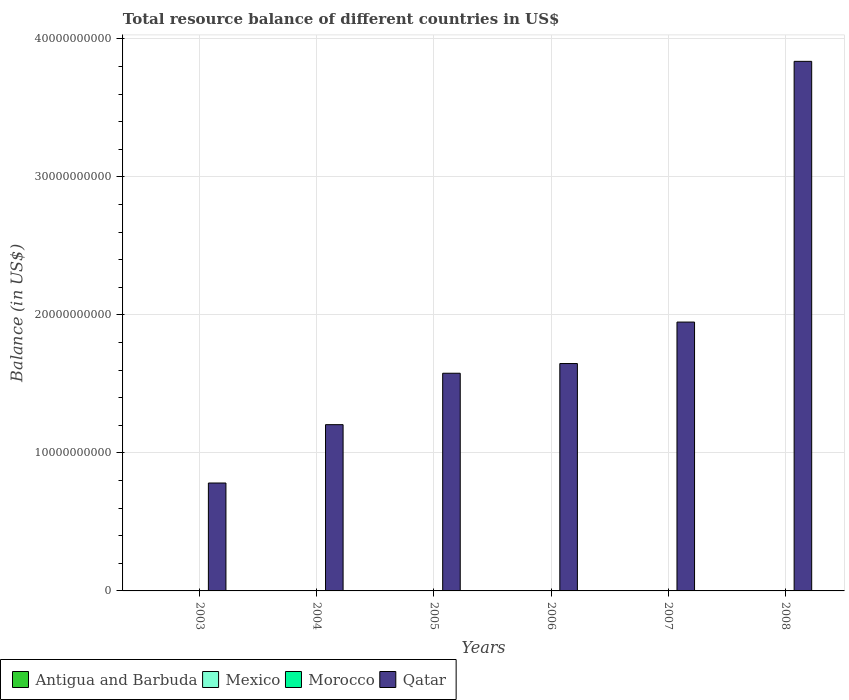How many different coloured bars are there?
Provide a short and direct response. 1. Are the number of bars per tick equal to the number of legend labels?
Your response must be concise. No. How many bars are there on the 6th tick from the left?
Offer a terse response. 1. What is the label of the 2nd group of bars from the left?
Keep it short and to the point. 2004. What is the total resource balance in Antigua and Barbuda in 2007?
Give a very brief answer. 0. Across all years, what is the maximum total resource balance in Qatar?
Ensure brevity in your answer.  3.84e+1. Across all years, what is the minimum total resource balance in Morocco?
Give a very brief answer. 0. What is the difference between the total resource balance in Qatar in 2007 and that in 2008?
Your answer should be compact. -1.89e+1. What is the difference between the total resource balance in Qatar in 2008 and the total resource balance in Antigua and Barbuda in 2005?
Ensure brevity in your answer.  3.84e+1. What is the average total resource balance in Antigua and Barbuda per year?
Make the answer very short. 0. What is the ratio of the total resource balance in Qatar in 2005 to that in 2007?
Make the answer very short. 0.81. Is the total resource balance in Qatar in 2006 less than that in 2008?
Provide a succinct answer. Yes. What is the difference between the highest and the second highest total resource balance in Qatar?
Provide a succinct answer. 1.89e+1. What is the difference between the highest and the lowest total resource balance in Qatar?
Your answer should be very brief. 3.06e+1. Is it the case that in every year, the sum of the total resource balance in Antigua and Barbuda and total resource balance in Morocco is greater than the sum of total resource balance in Qatar and total resource balance in Mexico?
Provide a short and direct response. No. Are all the bars in the graph horizontal?
Your answer should be compact. No. How many years are there in the graph?
Give a very brief answer. 6. What is the difference between two consecutive major ticks on the Y-axis?
Your answer should be compact. 1.00e+1. Are the values on the major ticks of Y-axis written in scientific E-notation?
Your answer should be very brief. No. Does the graph contain any zero values?
Make the answer very short. Yes. Does the graph contain grids?
Provide a succinct answer. Yes. How many legend labels are there?
Provide a short and direct response. 4. How are the legend labels stacked?
Ensure brevity in your answer.  Horizontal. What is the title of the graph?
Provide a short and direct response. Total resource balance of different countries in US$. What is the label or title of the X-axis?
Offer a very short reply. Years. What is the label or title of the Y-axis?
Ensure brevity in your answer.  Balance (in US$). What is the Balance (in US$) in Antigua and Barbuda in 2003?
Your response must be concise. 0. What is the Balance (in US$) in Mexico in 2003?
Offer a very short reply. 0. What is the Balance (in US$) of Morocco in 2003?
Give a very brief answer. 0. What is the Balance (in US$) of Qatar in 2003?
Keep it short and to the point. 7.82e+09. What is the Balance (in US$) of Mexico in 2004?
Offer a terse response. 0. What is the Balance (in US$) in Qatar in 2004?
Provide a succinct answer. 1.20e+1. What is the Balance (in US$) of Mexico in 2005?
Provide a short and direct response. 0. What is the Balance (in US$) of Qatar in 2005?
Your answer should be very brief. 1.58e+1. What is the Balance (in US$) of Mexico in 2006?
Make the answer very short. 0. What is the Balance (in US$) of Qatar in 2006?
Your response must be concise. 1.65e+1. What is the Balance (in US$) of Mexico in 2007?
Provide a succinct answer. 0. What is the Balance (in US$) of Morocco in 2007?
Ensure brevity in your answer.  0. What is the Balance (in US$) of Qatar in 2007?
Your response must be concise. 1.95e+1. What is the Balance (in US$) of Mexico in 2008?
Offer a very short reply. 0. What is the Balance (in US$) in Morocco in 2008?
Keep it short and to the point. 0. What is the Balance (in US$) in Qatar in 2008?
Your response must be concise. 3.84e+1. Across all years, what is the maximum Balance (in US$) in Qatar?
Provide a short and direct response. 3.84e+1. Across all years, what is the minimum Balance (in US$) of Qatar?
Offer a very short reply. 7.82e+09. What is the total Balance (in US$) in Antigua and Barbuda in the graph?
Offer a terse response. 0. What is the total Balance (in US$) in Mexico in the graph?
Your response must be concise. 0. What is the total Balance (in US$) of Qatar in the graph?
Your answer should be very brief. 1.10e+11. What is the difference between the Balance (in US$) of Qatar in 2003 and that in 2004?
Keep it short and to the point. -4.23e+09. What is the difference between the Balance (in US$) of Qatar in 2003 and that in 2005?
Your response must be concise. -7.95e+09. What is the difference between the Balance (in US$) of Qatar in 2003 and that in 2006?
Offer a terse response. -8.66e+09. What is the difference between the Balance (in US$) in Qatar in 2003 and that in 2007?
Your answer should be compact. -1.17e+1. What is the difference between the Balance (in US$) of Qatar in 2003 and that in 2008?
Ensure brevity in your answer.  -3.06e+1. What is the difference between the Balance (in US$) in Qatar in 2004 and that in 2005?
Your answer should be compact. -3.73e+09. What is the difference between the Balance (in US$) in Qatar in 2004 and that in 2006?
Make the answer very short. -4.43e+09. What is the difference between the Balance (in US$) in Qatar in 2004 and that in 2007?
Give a very brief answer. -7.43e+09. What is the difference between the Balance (in US$) in Qatar in 2004 and that in 2008?
Your response must be concise. -2.63e+1. What is the difference between the Balance (in US$) of Qatar in 2005 and that in 2006?
Keep it short and to the point. -7.03e+08. What is the difference between the Balance (in US$) in Qatar in 2005 and that in 2007?
Offer a very short reply. -3.71e+09. What is the difference between the Balance (in US$) of Qatar in 2005 and that in 2008?
Offer a very short reply. -2.26e+1. What is the difference between the Balance (in US$) of Qatar in 2006 and that in 2007?
Keep it short and to the point. -3.00e+09. What is the difference between the Balance (in US$) in Qatar in 2006 and that in 2008?
Provide a succinct answer. -2.19e+1. What is the difference between the Balance (in US$) in Qatar in 2007 and that in 2008?
Your response must be concise. -1.89e+1. What is the average Balance (in US$) of Qatar per year?
Provide a succinct answer. 1.83e+1. What is the ratio of the Balance (in US$) of Qatar in 2003 to that in 2004?
Ensure brevity in your answer.  0.65. What is the ratio of the Balance (in US$) in Qatar in 2003 to that in 2005?
Provide a succinct answer. 0.5. What is the ratio of the Balance (in US$) in Qatar in 2003 to that in 2006?
Offer a terse response. 0.47. What is the ratio of the Balance (in US$) of Qatar in 2003 to that in 2007?
Offer a very short reply. 0.4. What is the ratio of the Balance (in US$) of Qatar in 2003 to that in 2008?
Your response must be concise. 0.2. What is the ratio of the Balance (in US$) in Qatar in 2004 to that in 2005?
Give a very brief answer. 0.76. What is the ratio of the Balance (in US$) in Qatar in 2004 to that in 2006?
Provide a short and direct response. 0.73. What is the ratio of the Balance (in US$) in Qatar in 2004 to that in 2007?
Give a very brief answer. 0.62. What is the ratio of the Balance (in US$) of Qatar in 2004 to that in 2008?
Your answer should be very brief. 0.31. What is the ratio of the Balance (in US$) of Qatar in 2005 to that in 2006?
Offer a very short reply. 0.96. What is the ratio of the Balance (in US$) in Qatar in 2005 to that in 2007?
Make the answer very short. 0.81. What is the ratio of the Balance (in US$) in Qatar in 2005 to that in 2008?
Give a very brief answer. 0.41. What is the ratio of the Balance (in US$) of Qatar in 2006 to that in 2007?
Your answer should be compact. 0.85. What is the ratio of the Balance (in US$) in Qatar in 2006 to that in 2008?
Ensure brevity in your answer.  0.43. What is the ratio of the Balance (in US$) in Qatar in 2007 to that in 2008?
Offer a very short reply. 0.51. What is the difference between the highest and the second highest Balance (in US$) of Qatar?
Provide a short and direct response. 1.89e+1. What is the difference between the highest and the lowest Balance (in US$) of Qatar?
Keep it short and to the point. 3.06e+1. 